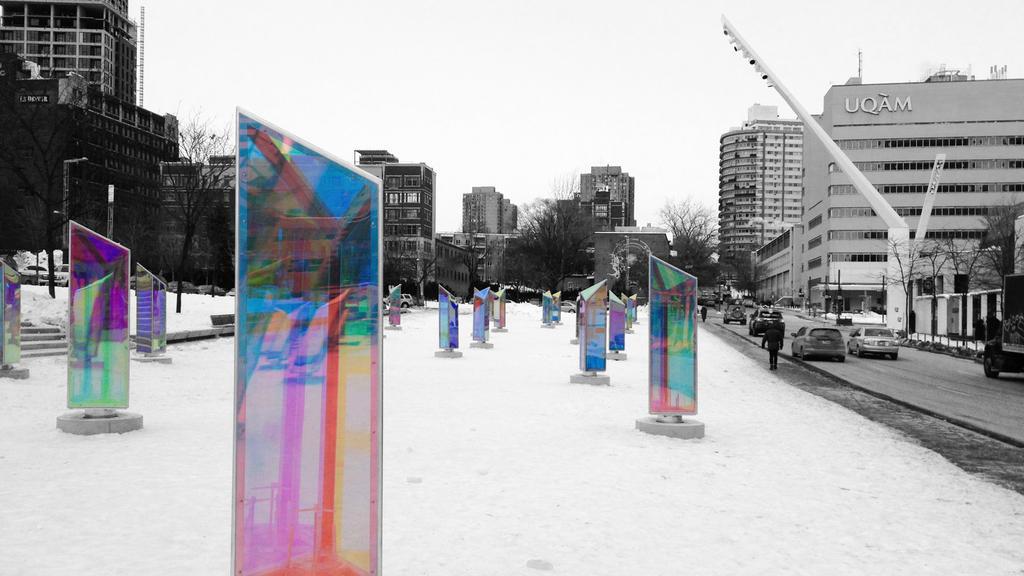Can you describe this image briefly? On the ground there is snow. On the snow there are glass walls on the stands. On the right side there is a road. On the road there are many vehicles. In this image we can see many trees. Also there are buildings. In the background there is sky. On the right side there are steps. 